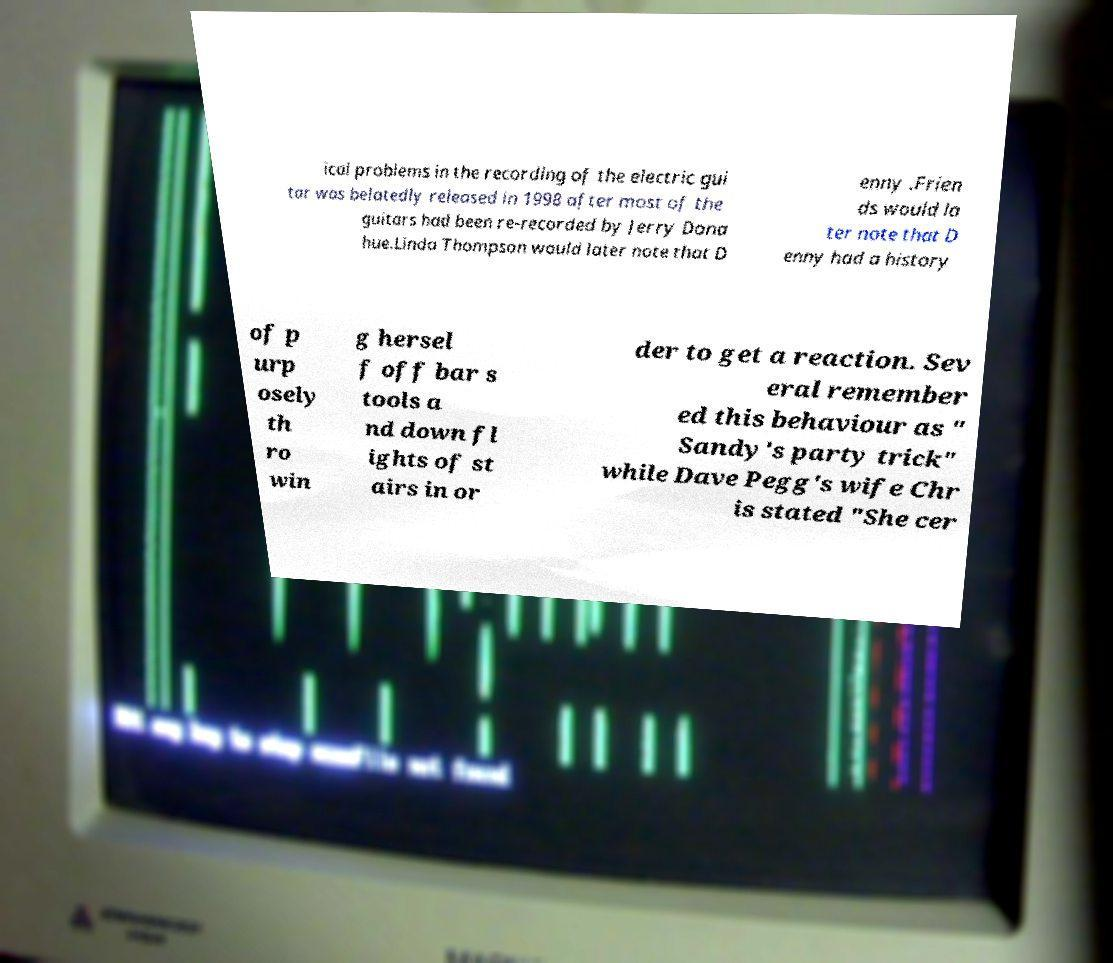Please identify and transcribe the text found in this image. ical problems in the recording of the electric gui tar was belatedly released in 1998 after most of the guitars had been re-recorded by Jerry Dona hue.Linda Thompson would later note that D enny .Frien ds would la ter note that D enny had a history of p urp osely th ro win g hersel f off bar s tools a nd down fl ights of st airs in or der to get a reaction. Sev eral remember ed this behaviour as " Sandy's party trick" while Dave Pegg's wife Chr is stated "She cer 